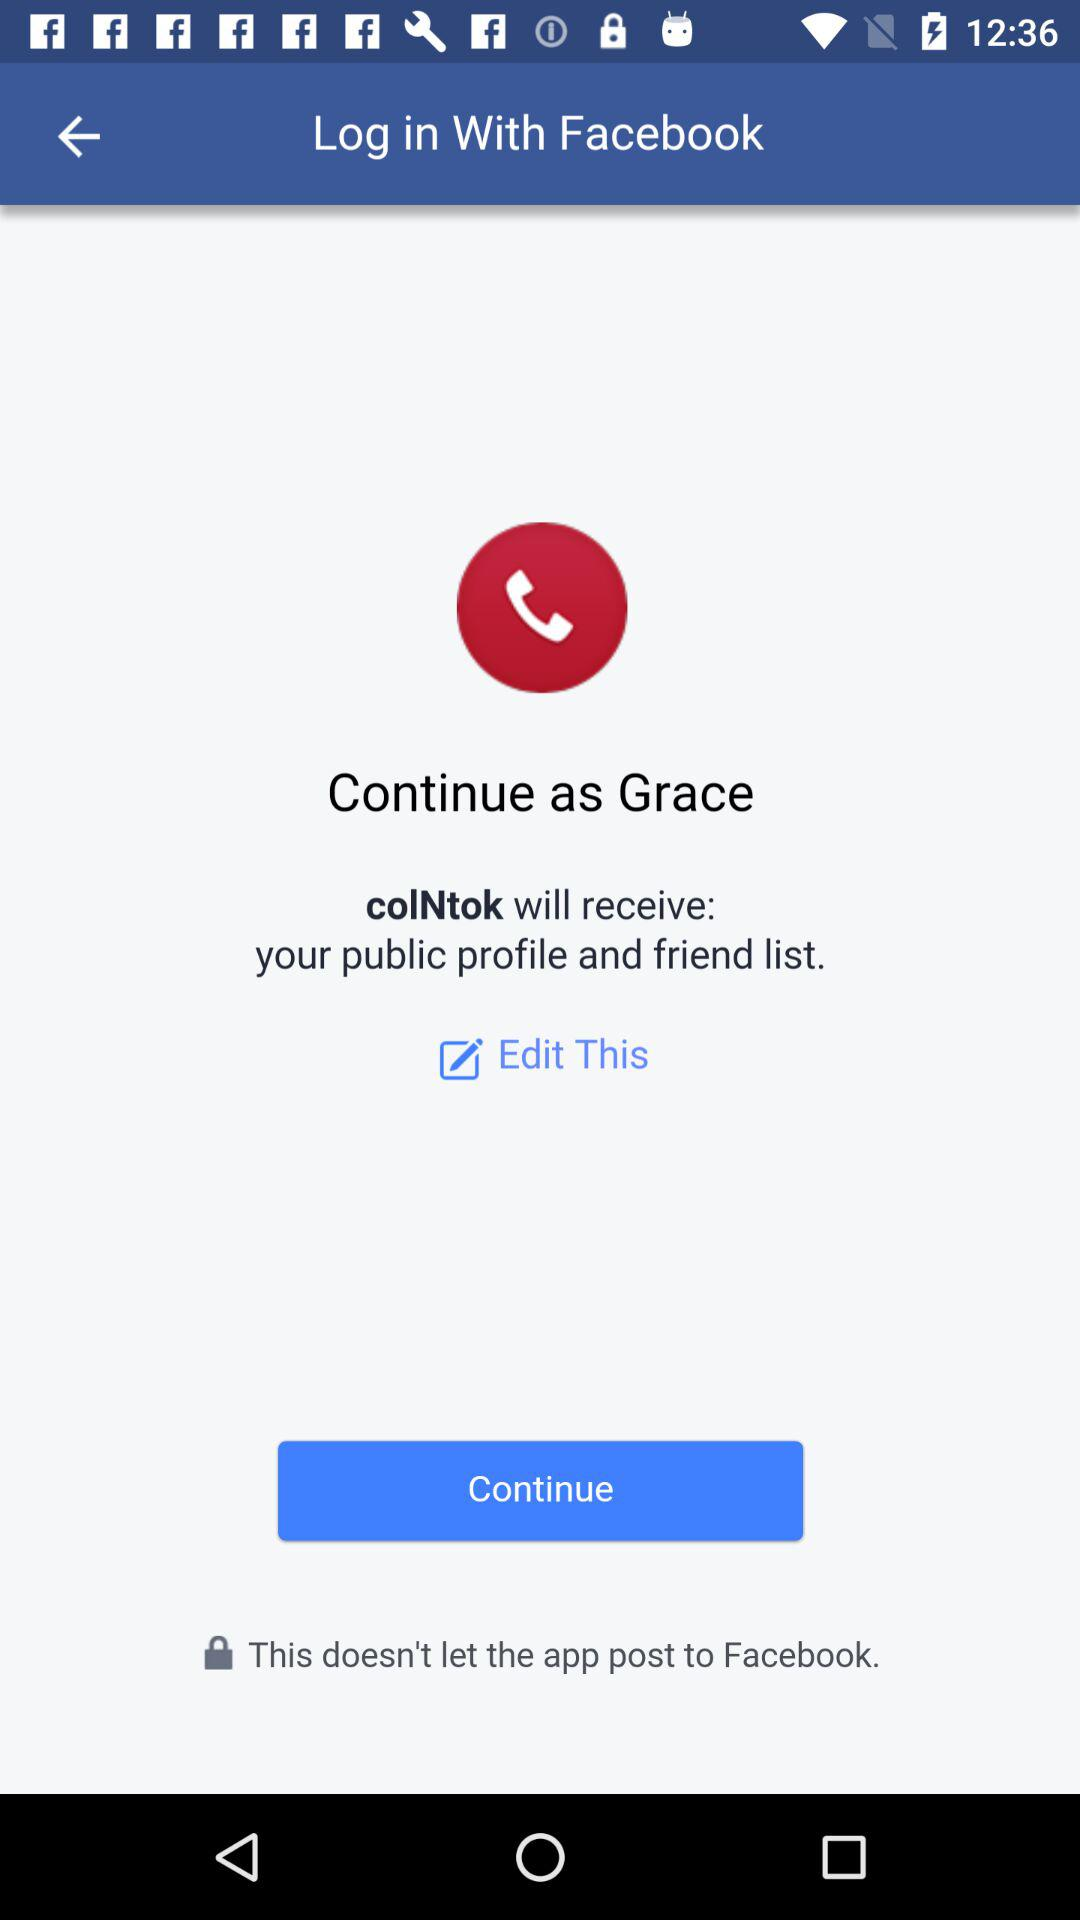Through what account can logging in be done? Logging in can be done through "Facebook" account. 